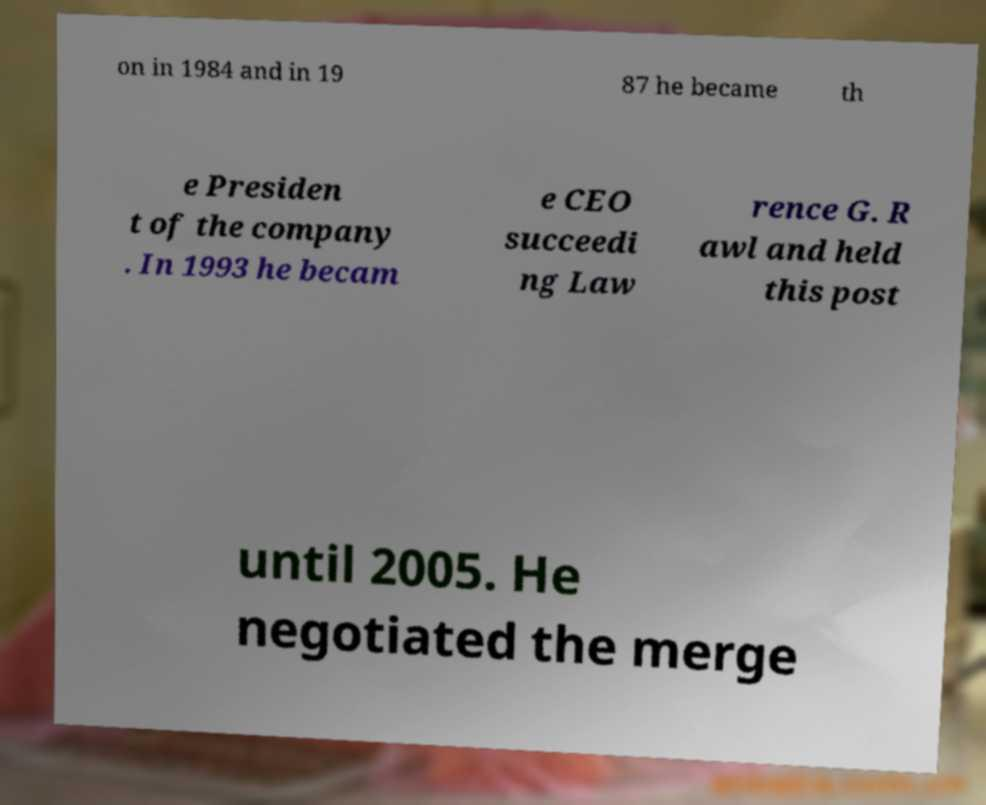There's text embedded in this image that I need extracted. Can you transcribe it verbatim? on in 1984 and in 19 87 he became th e Presiden t of the company . In 1993 he becam e CEO succeedi ng Law rence G. R awl and held this post until 2005. He negotiated the merge 